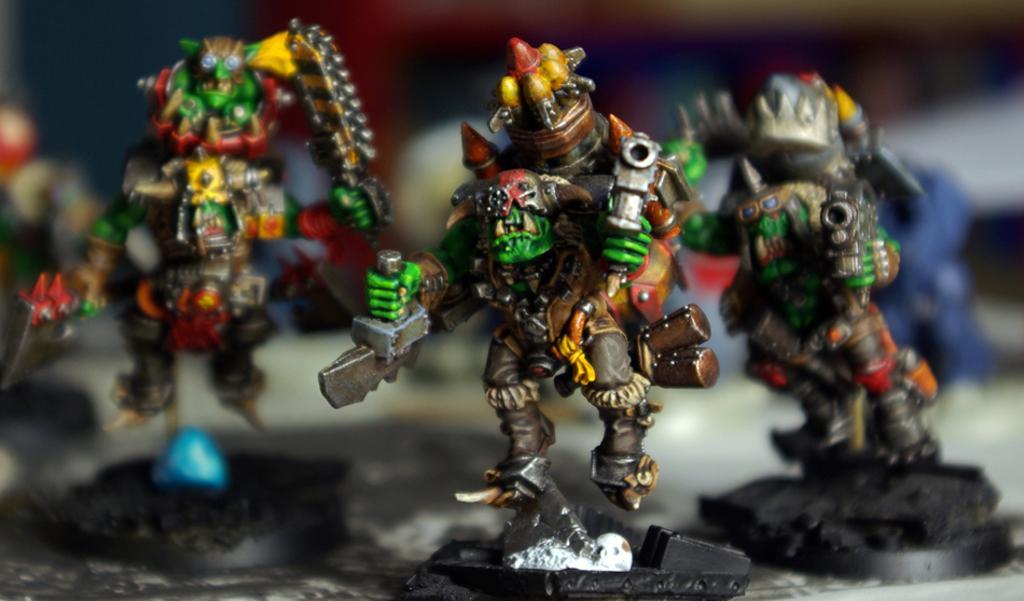Can you describe this image briefly? In this image I can see few toys which are green, black, red , brown, orange, silver and yellow in color. I can see the blurry background. 